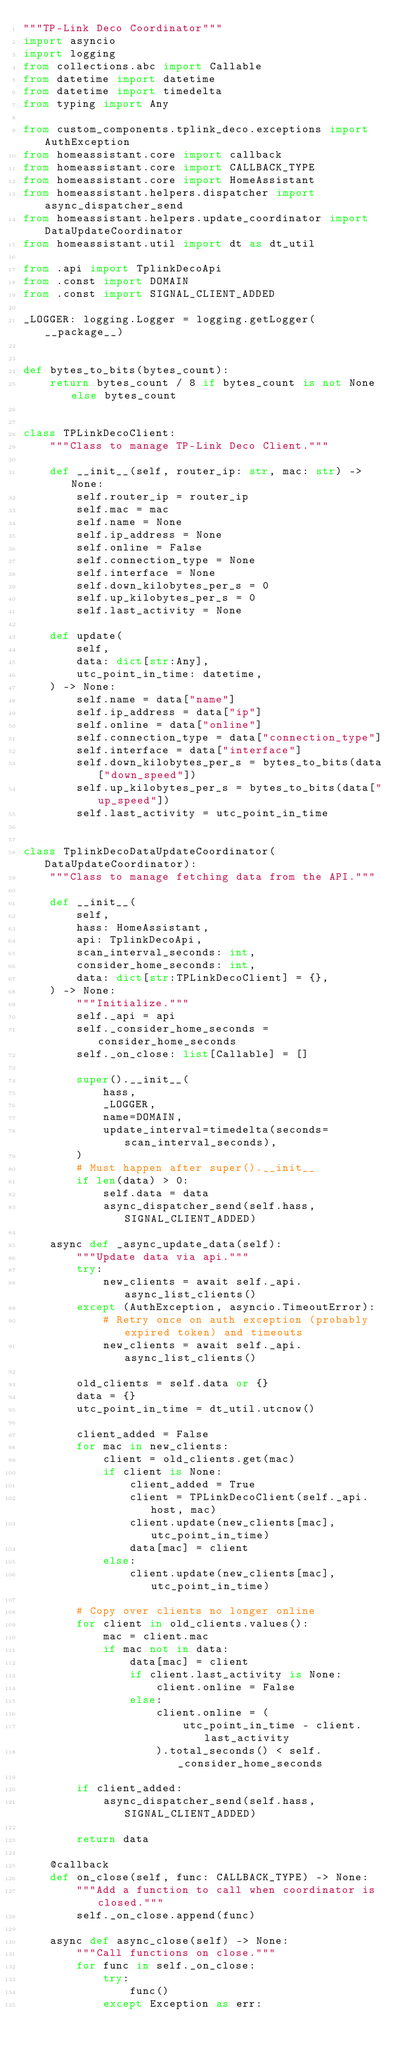<code> <loc_0><loc_0><loc_500><loc_500><_Python_>"""TP-Link Deco Coordinator"""
import asyncio
import logging
from collections.abc import Callable
from datetime import datetime
from datetime import timedelta
from typing import Any

from custom_components.tplink_deco.exceptions import AuthException
from homeassistant.core import callback
from homeassistant.core import CALLBACK_TYPE
from homeassistant.core import HomeAssistant
from homeassistant.helpers.dispatcher import async_dispatcher_send
from homeassistant.helpers.update_coordinator import DataUpdateCoordinator
from homeassistant.util import dt as dt_util

from .api import TplinkDecoApi
from .const import DOMAIN
from .const import SIGNAL_CLIENT_ADDED

_LOGGER: logging.Logger = logging.getLogger(__package__)


def bytes_to_bits(bytes_count):
    return bytes_count / 8 if bytes_count is not None else bytes_count


class TPLinkDecoClient:
    """Class to manage TP-Link Deco Client."""

    def __init__(self, router_ip: str, mac: str) -> None:
        self.router_ip = router_ip
        self.mac = mac
        self.name = None
        self.ip_address = None
        self.online = False
        self.connection_type = None
        self.interface = None
        self.down_kilobytes_per_s = 0
        self.up_kilobytes_per_s = 0
        self.last_activity = None

    def update(
        self,
        data: dict[str:Any],
        utc_point_in_time: datetime,
    ) -> None:
        self.name = data["name"]
        self.ip_address = data["ip"]
        self.online = data["online"]
        self.connection_type = data["connection_type"]
        self.interface = data["interface"]
        self.down_kilobytes_per_s = bytes_to_bits(data["down_speed"])
        self.up_kilobytes_per_s = bytes_to_bits(data["up_speed"])
        self.last_activity = utc_point_in_time


class TplinkDecoDataUpdateCoordinator(DataUpdateCoordinator):
    """Class to manage fetching data from the API."""

    def __init__(
        self,
        hass: HomeAssistant,
        api: TplinkDecoApi,
        scan_interval_seconds: int,
        consider_home_seconds: int,
        data: dict[str:TPLinkDecoClient] = {},
    ) -> None:
        """Initialize."""
        self._api = api
        self._consider_home_seconds = consider_home_seconds
        self._on_close: list[Callable] = []

        super().__init__(
            hass,
            _LOGGER,
            name=DOMAIN,
            update_interval=timedelta(seconds=scan_interval_seconds),
        )
        # Must happen after super().__init__
        if len(data) > 0:
            self.data = data
            async_dispatcher_send(self.hass, SIGNAL_CLIENT_ADDED)

    async def _async_update_data(self):
        """Update data via api."""
        try:
            new_clients = await self._api.async_list_clients()
        except (AuthException, asyncio.TimeoutError):
            # Retry once on auth exception (probably expired token) and timeouts
            new_clients = await self._api.async_list_clients()

        old_clients = self.data or {}
        data = {}
        utc_point_in_time = dt_util.utcnow()

        client_added = False
        for mac in new_clients:
            client = old_clients.get(mac)
            if client is None:
                client_added = True
                client = TPLinkDecoClient(self._api.host, mac)
                client.update(new_clients[mac], utc_point_in_time)
                data[mac] = client
            else:
                client.update(new_clients[mac], utc_point_in_time)

        # Copy over clients no longer online
        for client in old_clients.values():
            mac = client.mac
            if mac not in data:
                data[mac] = client
                if client.last_activity is None:
                    client.online = False
                else:
                    client.online = (
                        utc_point_in_time - client.last_activity
                    ).total_seconds() < self._consider_home_seconds

        if client_added:
            async_dispatcher_send(self.hass, SIGNAL_CLIENT_ADDED)

        return data

    @callback
    def on_close(self, func: CALLBACK_TYPE) -> None:
        """Add a function to call when coordinator is closed."""
        self._on_close.append(func)

    async def async_close(self) -> None:
        """Call functions on close."""
        for func in self._on_close:
            try:
                func()
            except Exception as err:</code> 